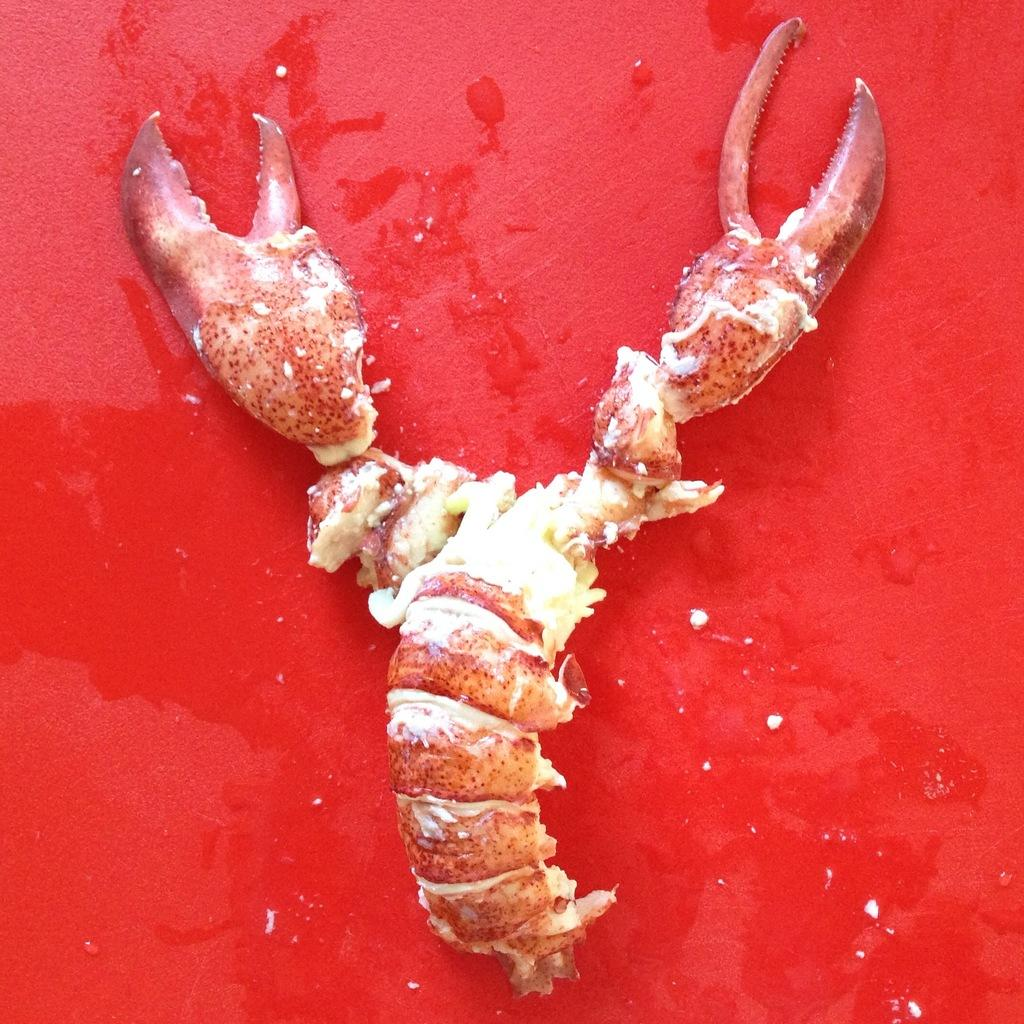What type of animal is in the image? There is a crab in the image. What color is the background of the image? The background color is red. Where is the seat located in the image? There is no seat present in the image. What type of chalk is being used by the crab in the image? There is no chalk or indication of writing in the image; it features a crab against a red background. 